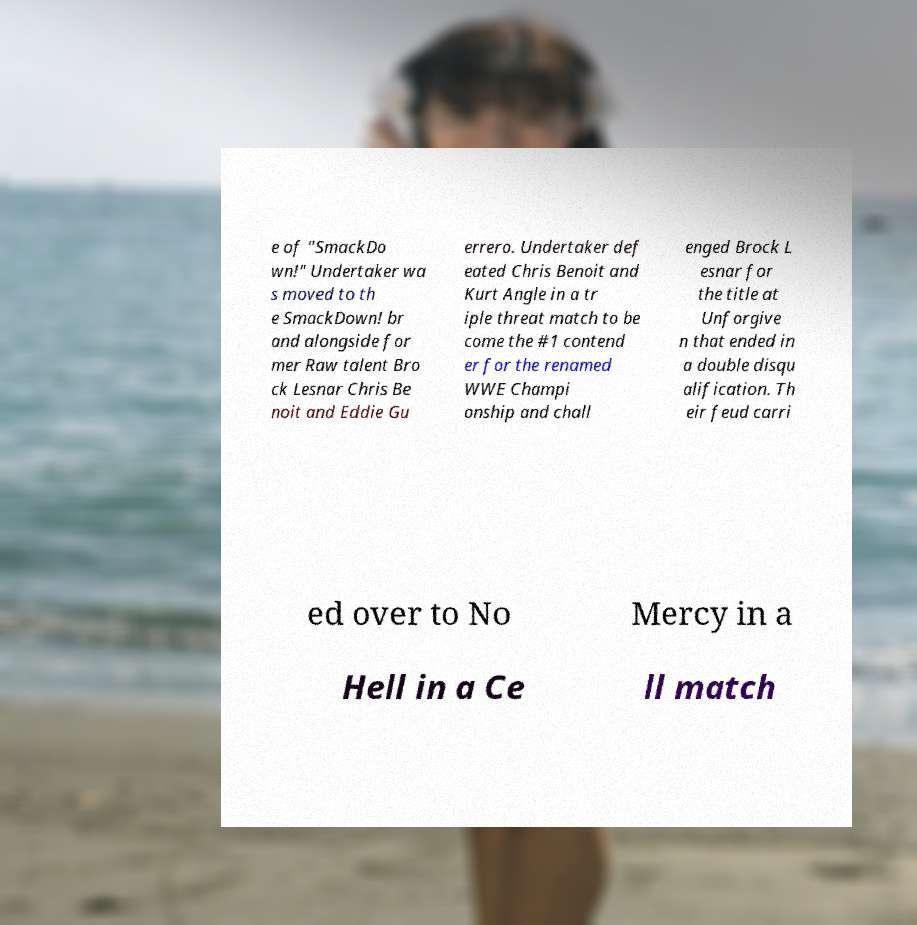I need the written content from this picture converted into text. Can you do that? e of "SmackDo wn!" Undertaker wa s moved to th e SmackDown! br and alongside for mer Raw talent Bro ck Lesnar Chris Be noit and Eddie Gu errero. Undertaker def eated Chris Benoit and Kurt Angle in a tr iple threat match to be come the #1 contend er for the renamed WWE Champi onship and chall enged Brock L esnar for the title at Unforgive n that ended in a double disqu alification. Th eir feud carri ed over to No Mercy in a Hell in a Ce ll match 